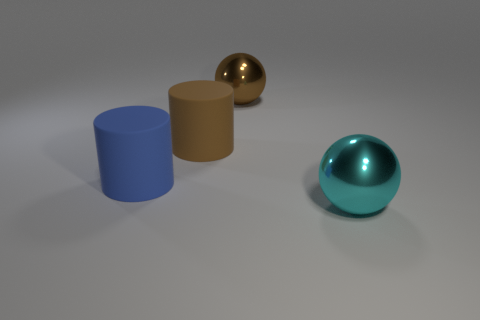How many brown spheres have the same material as the large cyan thing?
Your answer should be compact. 1. There is a sphere that is in front of the big metallic sphere that is behind the large rubber cylinder behind the blue matte cylinder; what is its color?
Provide a succinct answer. Cyan. Do the brown cylinder and the blue object have the same size?
Make the answer very short. Yes. Is there anything else that is the same shape as the big blue object?
Make the answer very short. Yes. What number of objects are either large brown objects that are to the left of the big brown shiny thing or tiny purple metallic spheres?
Give a very brief answer. 1. Does the large blue thing have the same shape as the cyan shiny thing?
Keep it short and to the point. No. How many other things are the same size as the brown sphere?
Your response must be concise. 3. What number of big objects are either brown metallic things or metal spheres?
Your answer should be very brief. 2. Do the matte object in front of the big brown rubber object and the thing in front of the big blue matte thing have the same size?
Give a very brief answer. Yes. There is a blue rubber object that is the same shape as the brown matte thing; what is its size?
Your answer should be very brief. Large. 